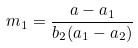<formula> <loc_0><loc_0><loc_500><loc_500>m _ { 1 } = \frac { a - a _ { 1 } } { b _ { 2 } ( a _ { 1 } - a _ { 2 } ) }</formula> 